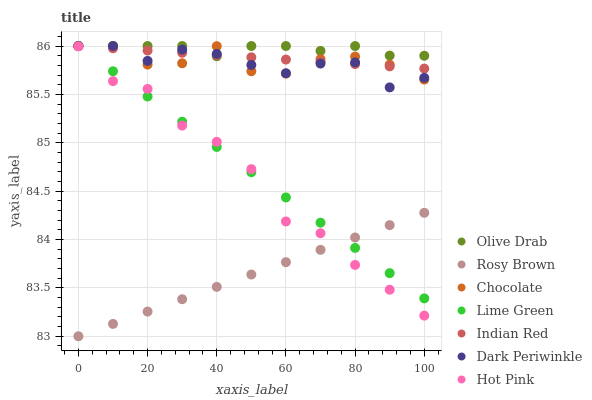Does Rosy Brown have the minimum area under the curve?
Answer yes or no. Yes. Does Olive Drab have the maximum area under the curve?
Answer yes or no. Yes. Does Chocolate have the minimum area under the curve?
Answer yes or no. No. Does Chocolate have the maximum area under the curve?
Answer yes or no. No. Is Lime Green the smoothest?
Answer yes or no. Yes. Is Hot Pink the roughest?
Answer yes or no. Yes. Is Rosy Brown the smoothest?
Answer yes or no. No. Is Rosy Brown the roughest?
Answer yes or no. No. Does Rosy Brown have the lowest value?
Answer yes or no. Yes. Does Chocolate have the lowest value?
Answer yes or no. No. Does Olive Drab have the highest value?
Answer yes or no. Yes. Does Rosy Brown have the highest value?
Answer yes or no. No. Is Hot Pink less than Dark Periwinkle?
Answer yes or no. Yes. Is Indian Red greater than Hot Pink?
Answer yes or no. Yes. Does Rosy Brown intersect Lime Green?
Answer yes or no. Yes. Is Rosy Brown less than Lime Green?
Answer yes or no. No. Is Rosy Brown greater than Lime Green?
Answer yes or no. No. Does Hot Pink intersect Dark Periwinkle?
Answer yes or no. No. 